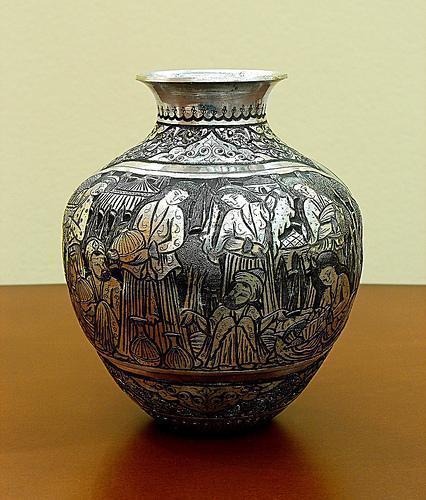How many people on the vase are holding a vase?
Give a very brief answer. 3. How many bearded men are on the vase?
Give a very brief answer. 2. 